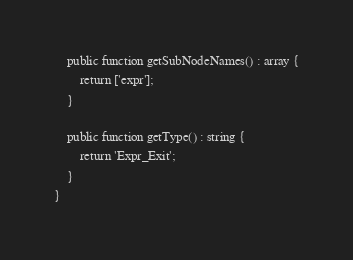<code> <loc_0><loc_0><loc_500><loc_500><_PHP_>    public function getSubNodeNames() : array {
        return ['expr'];
    }
    
    public function getType() : string {
        return 'Expr_Exit';
    }
}
</code> 